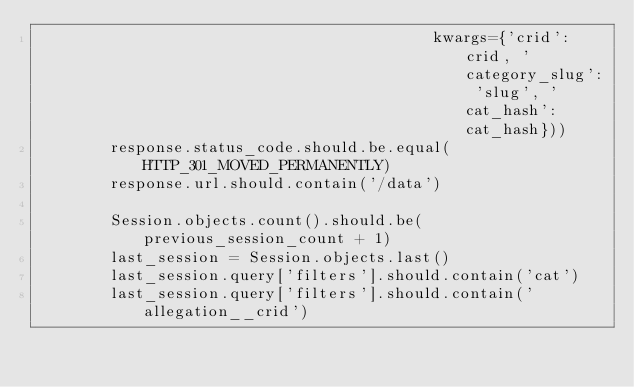Convert code to text. <code><loc_0><loc_0><loc_500><loc_500><_Python_>                                           kwargs={'crid': crid, 'category_slug': 'slug', 'cat_hash': cat_hash}))
        response.status_code.should.be.equal(HTTP_301_MOVED_PERMANENTLY)
        response.url.should.contain('/data')

        Session.objects.count().should.be(previous_session_count + 1)
        last_session = Session.objects.last()
        last_session.query['filters'].should.contain('cat')
        last_session.query['filters'].should.contain('allegation__crid')
</code> 